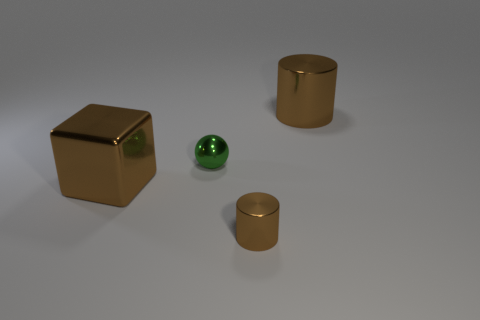Add 3 shiny spheres. How many objects exist? 7 Subtract all spheres. How many objects are left? 3 Subtract 0 gray cylinders. How many objects are left? 4 Subtract all tiny blue matte cylinders. Subtract all small shiny objects. How many objects are left? 2 Add 4 green things. How many green things are left? 5 Add 3 small blue rubber blocks. How many small blue rubber blocks exist? 3 